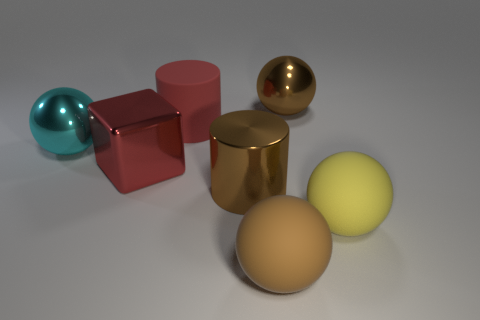What textures are visible in the objects shown? In this image, we observe a diversity of textures. The blue sphere has a transparent, glossy texture. The red cube and the golden cylinder exhibit reflective, shiny surfaces, while the large and small yellow spheres have a matte finish. 